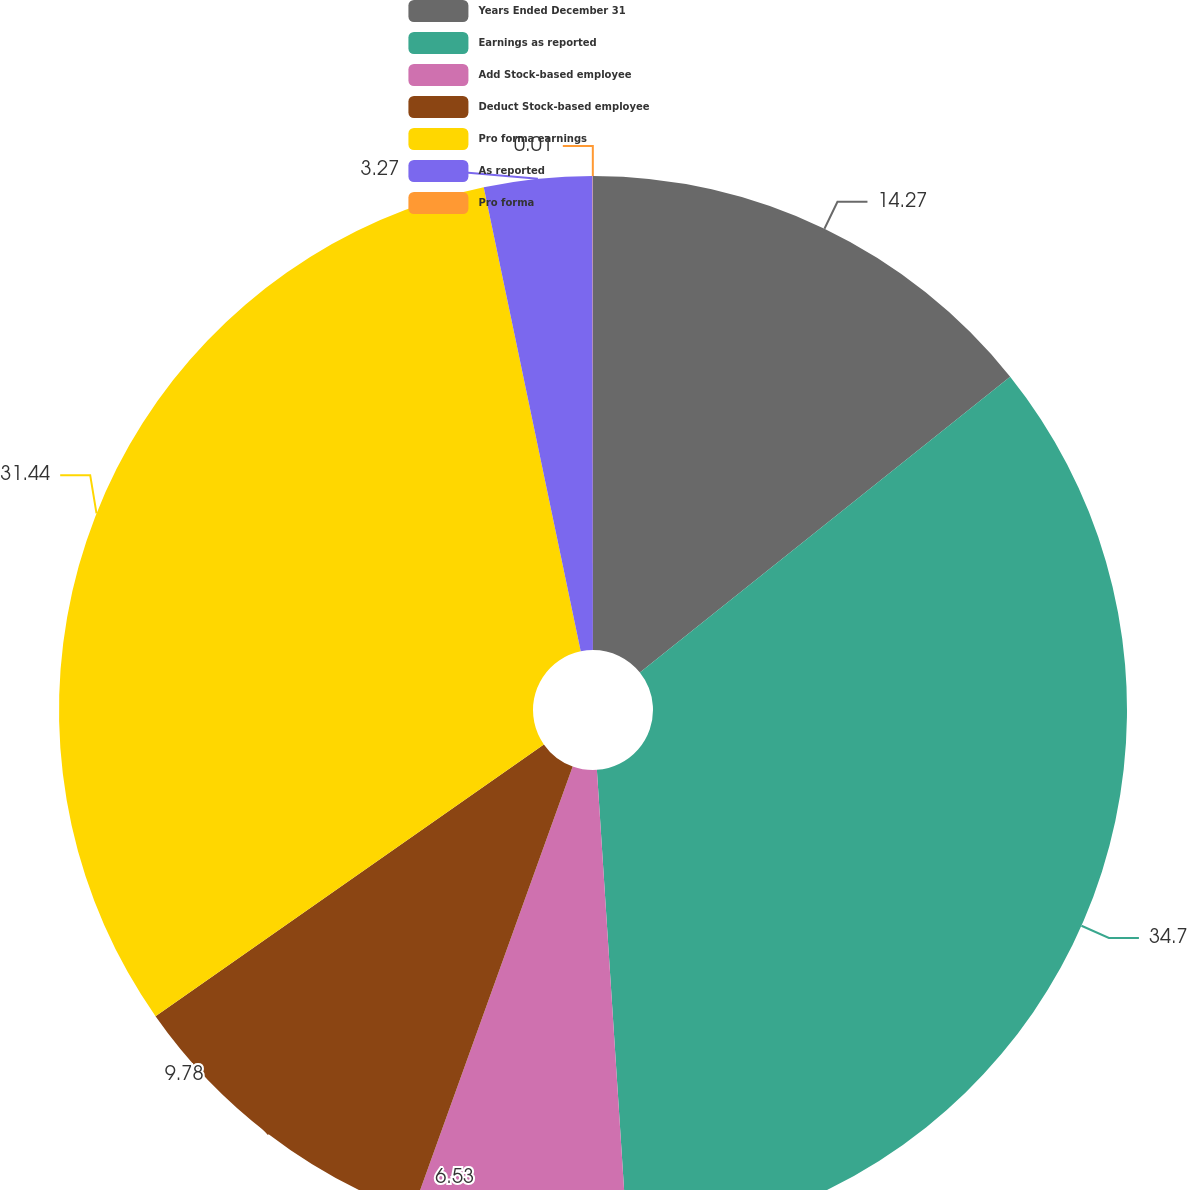Convert chart to OTSL. <chart><loc_0><loc_0><loc_500><loc_500><pie_chart><fcel>Years Ended December 31<fcel>Earnings as reported<fcel>Add Stock-based employee<fcel>Deduct Stock-based employee<fcel>Pro forma earnings<fcel>As reported<fcel>Pro forma<nl><fcel>14.27%<fcel>34.7%<fcel>6.53%<fcel>9.78%<fcel>31.44%<fcel>3.27%<fcel>0.01%<nl></chart> 